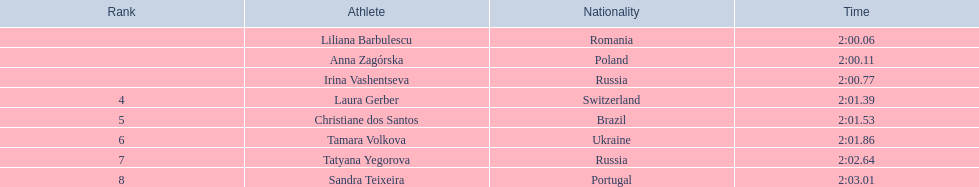Can you provide the monikers of the participants? Liliana Barbulescu, Anna Zagórska, Irina Vashentseva, Laura Gerber, Christiane dos Santos, Tamara Volkova, Tatyana Yegorova, Sandra Teixeira. Which finalist had the fastest finish? Liliana Barbulescu. 